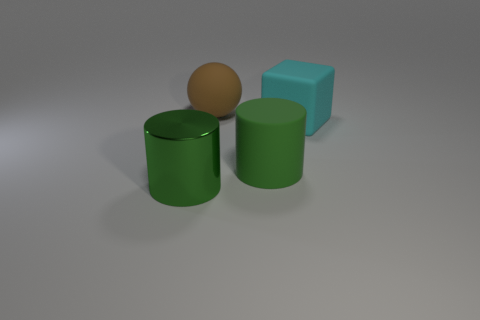The big rubber block has what color?
Give a very brief answer. Cyan. What number of tiny objects are either cyan things or matte objects?
Offer a terse response. 0. There is another large cylinder that is the same color as the big shiny cylinder; what material is it?
Ensure brevity in your answer.  Rubber. Do the large object that is in front of the big rubber cylinder and the object that is behind the rubber block have the same material?
Give a very brief answer. No. Is there a large yellow ball?
Provide a short and direct response. No. Is the number of big green shiny cylinders to the right of the large brown thing greater than the number of matte cylinders in front of the shiny object?
Keep it short and to the point. No. What material is the other large thing that is the same shape as the large green metal thing?
Your answer should be compact. Rubber. Is there any other thing that has the same size as the green metal cylinder?
Offer a very short reply. Yes. Does the cylinder that is to the left of the rubber sphere have the same color as the big cylinder that is to the right of the big brown rubber object?
Ensure brevity in your answer.  Yes. The big green matte thing is what shape?
Give a very brief answer. Cylinder. 